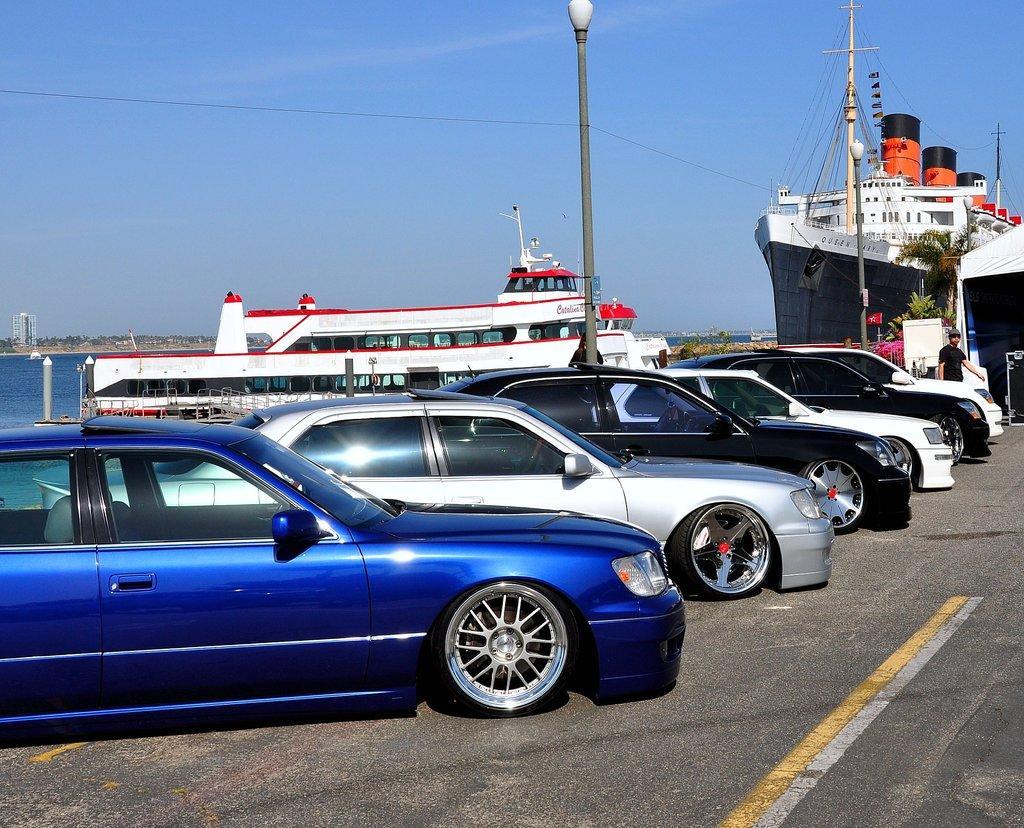Can you describe this image briefly? This is an outside view. Here I can see few cars on the road facing towards the right side. In the background, I can see two ships on the water and also there are two poles. On the right side, I can see a person walking on the road and also there is a white color shade. On the left side, I can see a building and trees. On the top of the image I can see the sky. 